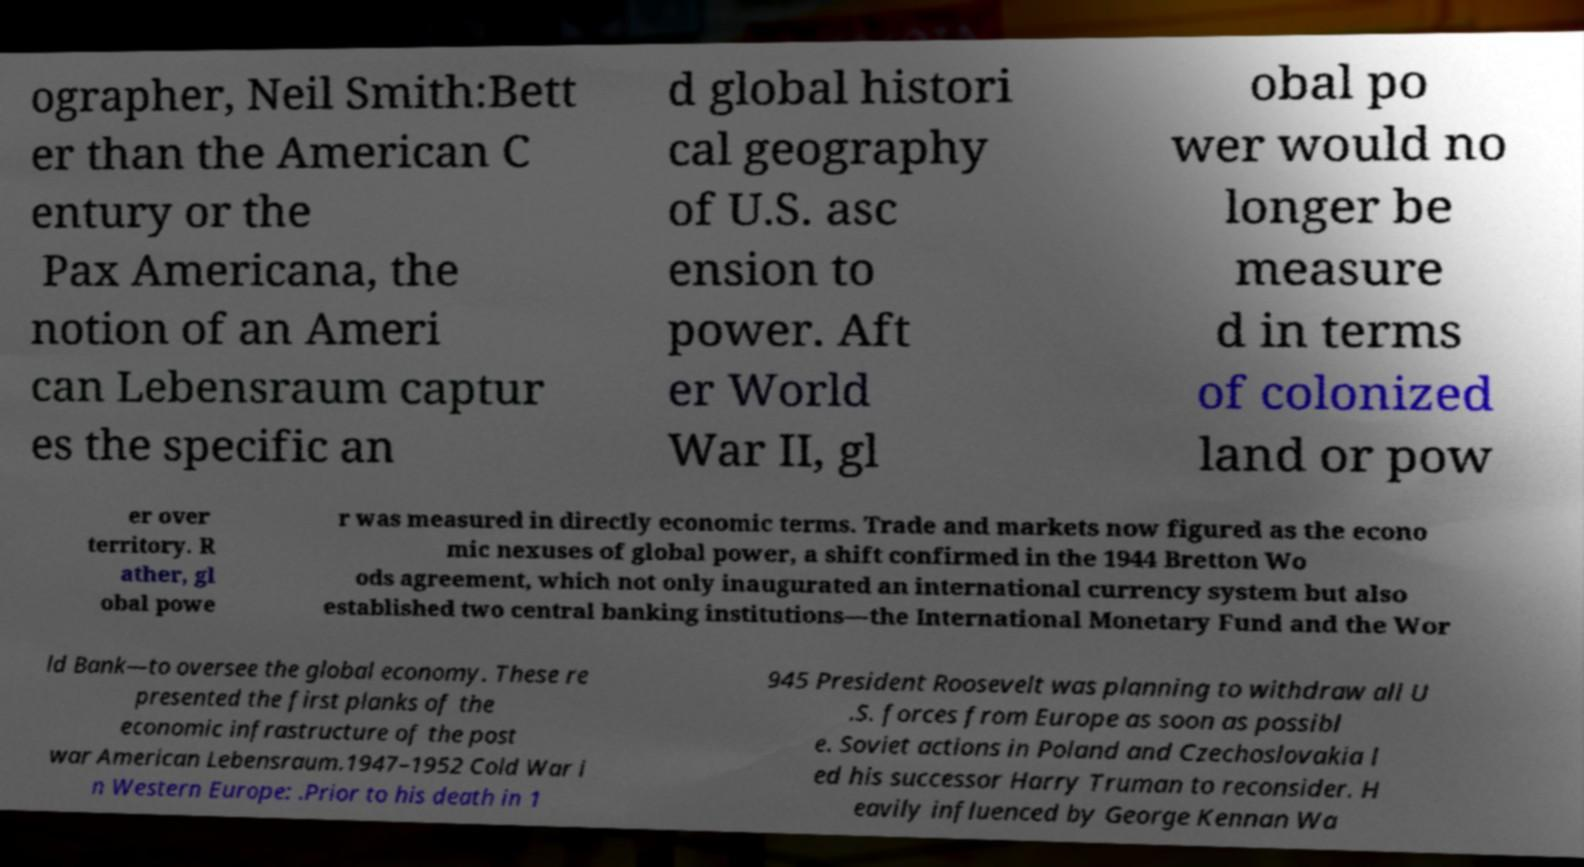What messages or text are displayed in this image? I need them in a readable, typed format. ographer, Neil Smith:Bett er than the American C entury or the Pax Americana, the notion of an Ameri can Lebensraum captur es the specific an d global histori cal geography of U.S. asc ension to power. Aft er World War II, gl obal po wer would no longer be measure d in terms of colonized land or pow er over territory. R ather, gl obal powe r was measured in directly economic terms. Trade and markets now figured as the econo mic nexuses of global power, a shift confirmed in the 1944 Bretton Wo ods agreement, which not only inaugurated an international currency system but also established two central banking institutions—the International Monetary Fund and the Wor ld Bank—to oversee the global economy. These re presented the first planks of the economic infrastructure of the post war American Lebensraum.1947–1952 Cold War i n Western Europe: .Prior to his death in 1 945 President Roosevelt was planning to withdraw all U .S. forces from Europe as soon as possibl e. Soviet actions in Poland and Czechoslovakia l ed his successor Harry Truman to reconsider. H eavily influenced by George Kennan Wa 